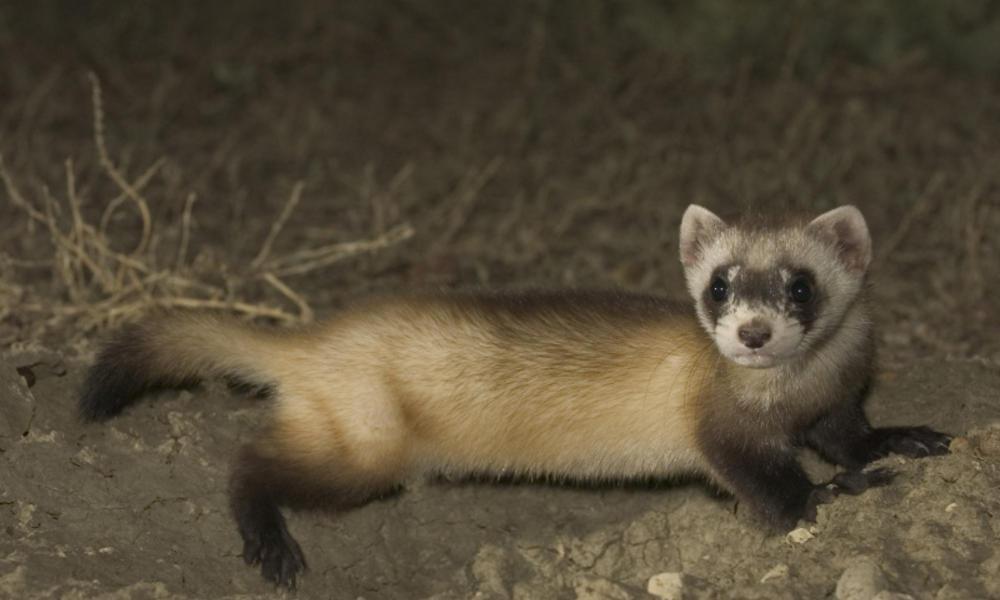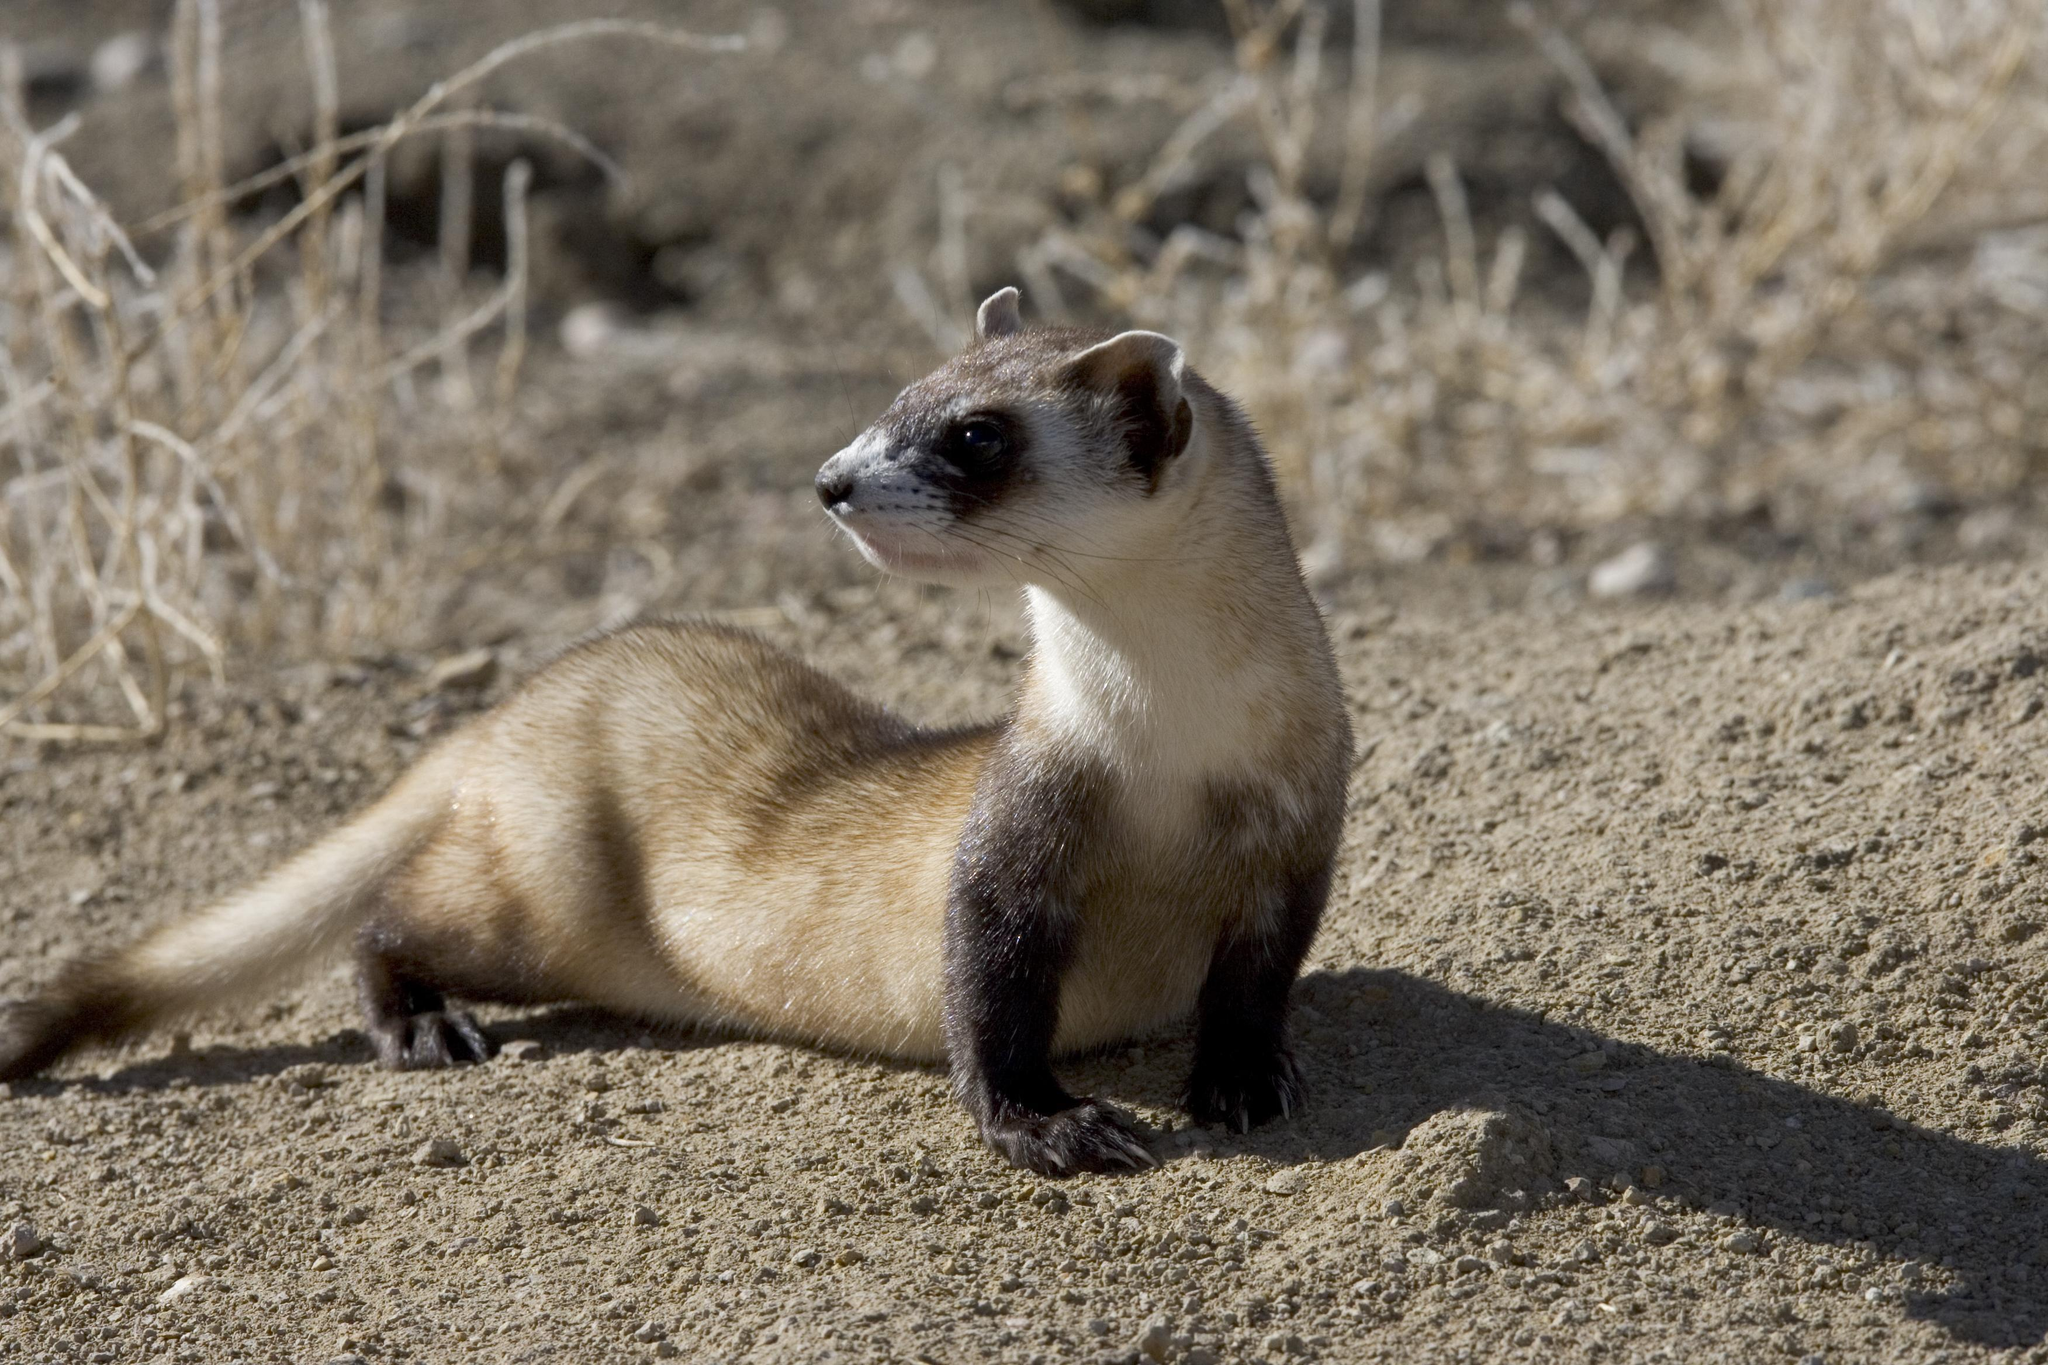The first image is the image on the left, the second image is the image on the right. Analyze the images presented: Is the assertion "All bodies of the animals pictured are facing right." valid? Answer yes or no. Yes. The first image is the image on the left, the second image is the image on the right. For the images shown, is this caption "One image shows a ferret with raised head, and body turned to the left." true? Answer yes or no. No. The first image is the image on the left, the second image is the image on the right. Examine the images to the left and right. Is the description "The animal in the image on the right is in side profile turned toward the left with its face turned toward the camera." accurate? Answer yes or no. No. 